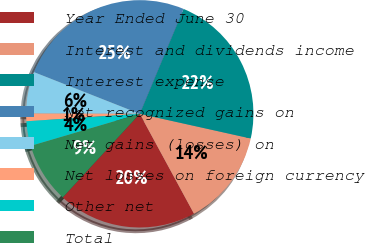Convert chart to OTSL. <chart><loc_0><loc_0><loc_500><loc_500><pie_chart><fcel>Year Ended June 30<fcel>Interest and dividends income<fcel>Interest expense<fcel>Net recognized gains on<fcel>Net gains (losses) on<fcel>Net losses on foreign currency<fcel>Other net<fcel>Total<nl><fcel>19.77%<fcel>13.6%<fcel>22.19%<fcel>25.32%<fcel>5.93%<fcel>1.09%<fcel>3.51%<fcel>8.59%<nl></chart> 